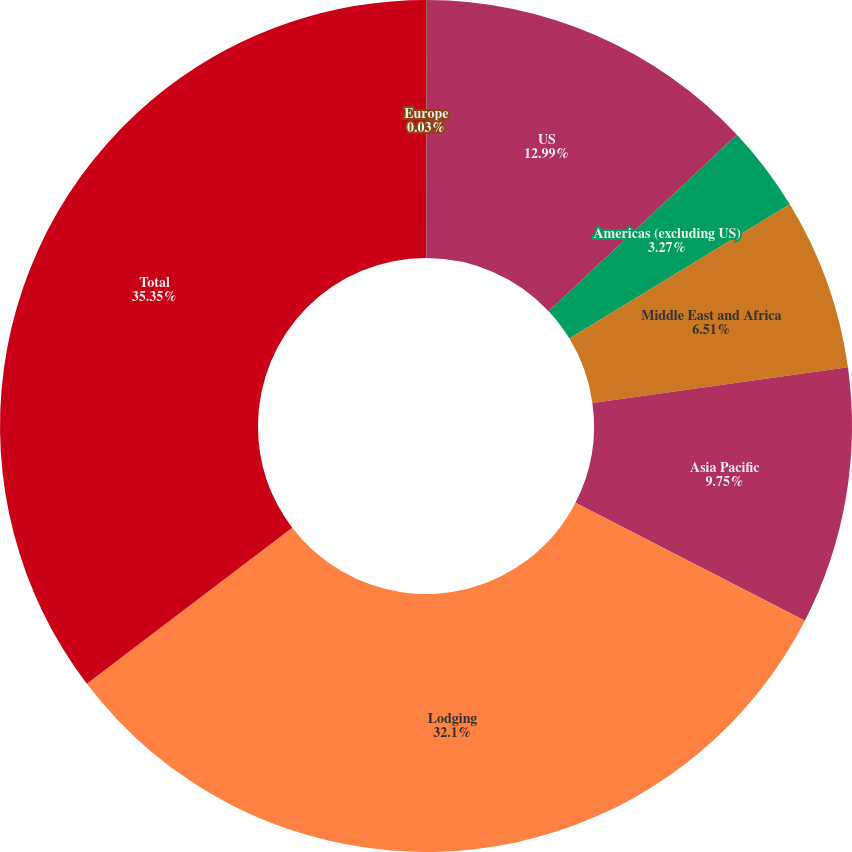<chart> <loc_0><loc_0><loc_500><loc_500><pie_chart><fcel>Europe<fcel>US<fcel>Americas (excluding US)<fcel>Middle East and Africa<fcel>Asia Pacific<fcel>Lodging<fcel>Total<nl><fcel>0.03%<fcel>12.99%<fcel>3.27%<fcel>6.51%<fcel>9.75%<fcel>32.1%<fcel>35.34%<nl></chart> 